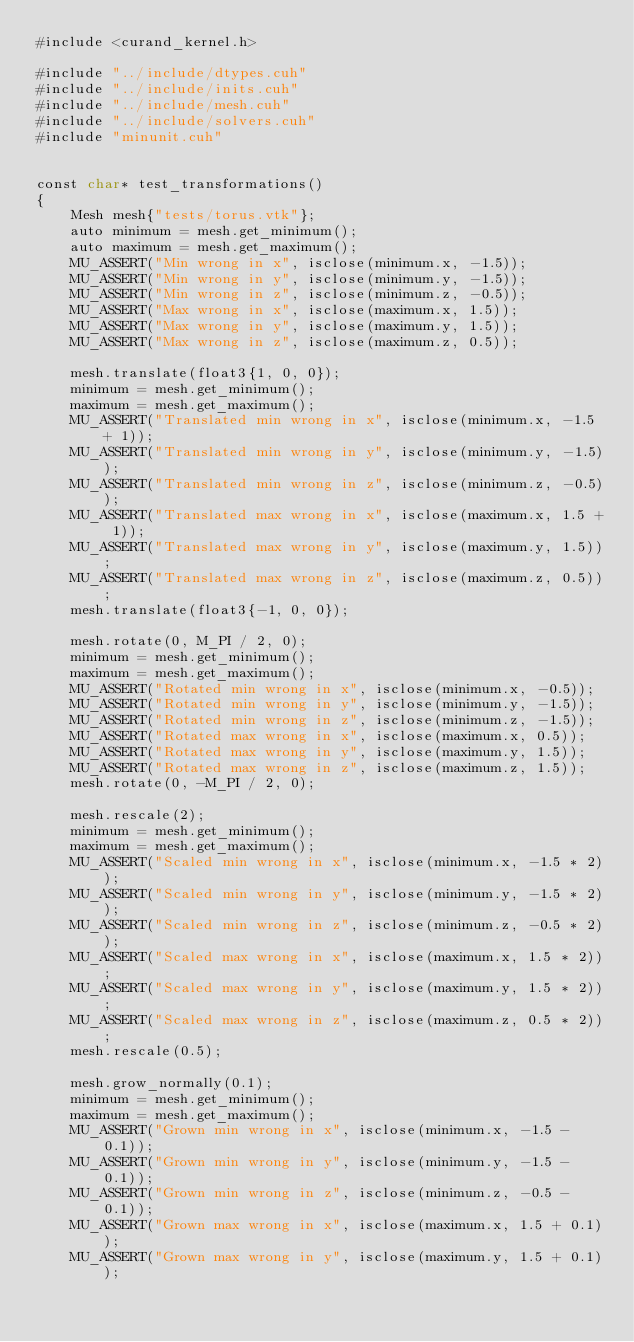<code> <loc_0><loc_0><loc_500><loc_500><_Cuda_>#include <curand_kernel.h>

#include "../include/dtypes.cuh"
#include "../include/inits.cuh"
#include "../include/mesh.cuh"
#include "../include/solvers.cuh"
#include "minunit.cuh"


const char* test_transformations()
{
    Mesh mesh{"tests/torus.vtk"};
    auto minimum = mesh.get_minimum();
    auto maximum = mesh.get_maximum();
    MU_ASSERT("Min wrong in x", isclose(minimum.x, -1.5));
    MU_ASSERT("Min wrong in y", isclose(minimum.y, -1.5));
    MU_ASSERT("Min wrong in z", isclose(minimum.z, -0.5));
    MU_ASSERT("Max wrong in x", isclose(maximum.x, 1.5));
    MU_ASSERT("Max wrong in y", isclose(maximum.y, 1.5));
    MU_ASSERT("Max wrong in z", isclose(maximum.z, 0.5));

    mesh.translate(float3{1, 0, 0});
    minimum = mesh.get_minimum();
    maximum = mesh.get_maximum();
    MU_ASSERT("Translated min wrong in x", isclose(minimum.x, -1.5 + 1));
    MU_ASSERT("Translated min wrong in y", isclose(minimum.y, -1.5));
    MU_ASSERT("Translated min wrong in z", isclose(minimum.z, -0.5));
    MU_ASSERT("Translated max wrong in x", isclose(maximum.x, 1.5 + 1));
    MU_ASSERT("Translated max wrong in y", isclose(maximum.y, 1.5));
    MU_ASSERT("Translated max wrong in z", isclose(maximum.z, 0.5));
    mesh.translate(float3{-1, 0, 0});

    mesh.rotate(0, M_PI / 2, 0);
    minimum = mesh.get_minimum();
    maximum = mesh.get_maximum();
    MU_ASSERT("Rotated min wrong in x", isclose(minimum.x, -0.5));
    MU_ASSERT("Rotated min wrong in y", isclose(minimum.y, -1.5));
    MU_ASSERT("Rotated min wrong in z", isclose(minimum.z, -1.5));
    MU_ASSERT("Rotated max wrong in x", isclose(maximum.x, 0.5));
    MU_ASSERT("Rotated max wrong in y", isclose(maximum.y, 1.5));
    MU_ASSERT("Rotated max wrong in z", isclose(maximum.z, 1.5));
    mesh.rotate(0, -M_PI / 2, 0);

    mesh.rescale(2);
    minimum = mesh.get_minimum();
    maximum = mesh.get_maximum();
    MU_ASSERT("Scaled min wrong in x", isclose(minimum.x, -1.5 * 2));
    MU_ASSERT("Scaled min wrong in y", isclose(minimum.y, -1.5 * 2));
    MU_ASSERT("Scaled min wrong in z", isclose(minimum.z, -0.5 * 2));
    MU_ASSERT("Scaled max wrong in x", isclose(maximum.x, 1.5 * 2));
    MU_ASSERT("Scaled max wrong in y", isclose(maximum.y, 1.5 * 2));
    MU_ASSERT("Scaled max wrong in z", isclose(maximum.z, 0.5 * 2));
    mesh.rescale(0.5);

    mesh.grow_normally(0.1);
    minimum = mesh.get_minimum();
    maximum = mesh.get_maximum();
    MU_ASSERT("Grown min wrong in x", isclose(minimum.x, -1.5 - 0.1));
    MU_ASSERT("Grown min wrong in y", isclose(minimum.y, -1.5 - 0.1));
    MU_ASSERT("Grown min wrong in z", isclose(minimum.z, -0.5 - 0.1));
    MU_ASSERT("Grown max wrong in x", isclose(maximum.x, 1.5 + 0.1));
    MU_ASSERT("Grown max wrong in y", isclose(maximum.y, 1.5 + 0.1));</code> 